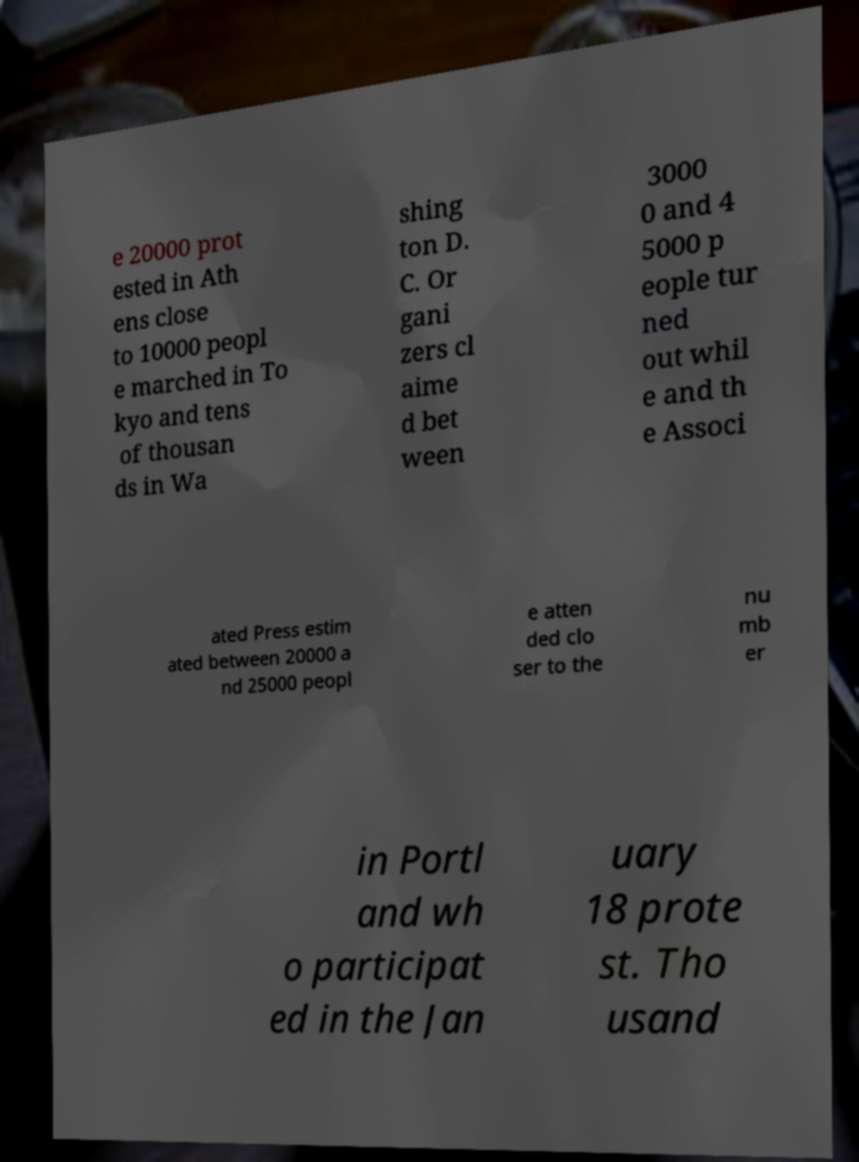Could you extract and type out the text from this image? e 20000 prot ested in Ath ens close to 10000 peopl e marched in To kyo and tens of thousan ds in Wa shing ton D. C. Or gani zers cl aime d bet ween 3000 0 and 4 5000 p eople tur ned out whil e and th e Associ ated Press estim ated between 20000 a nd 25000 peopl e atten ded clo ser to the nu mb er in Portl and wh o participat ed in the Jan uary 18 prote st. Tho usand 